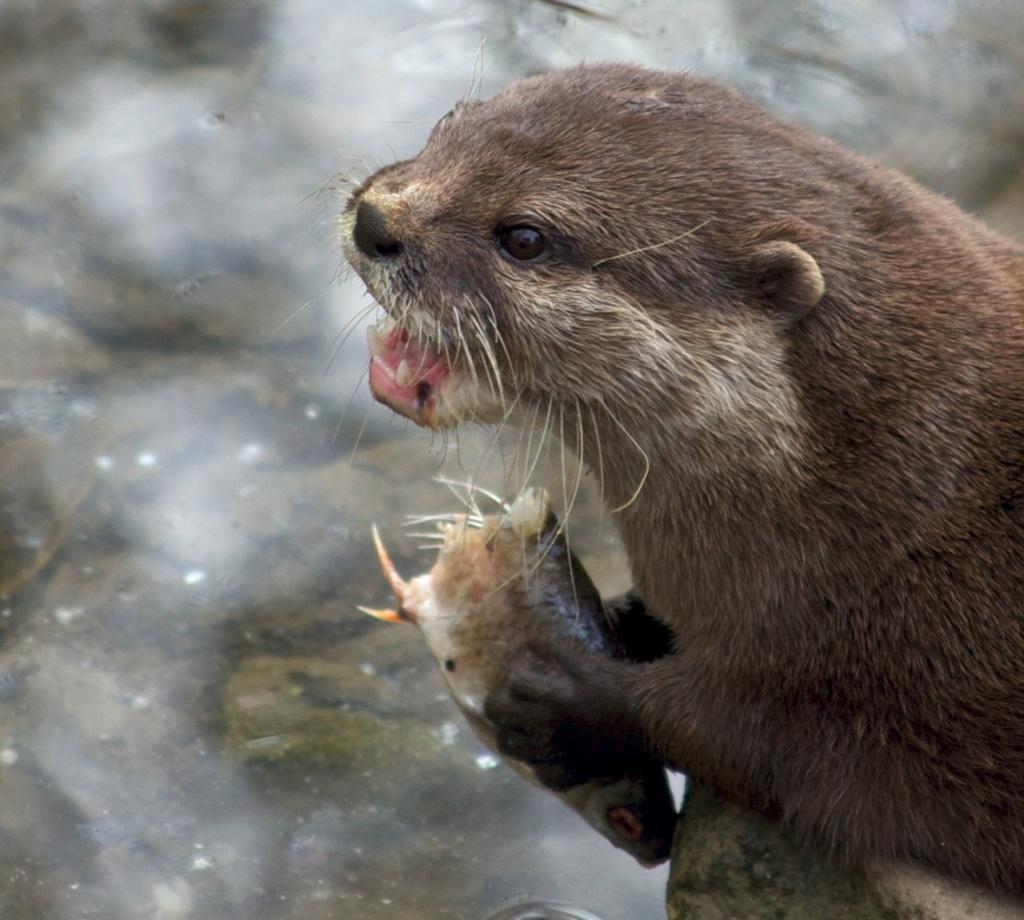Can you describe this image briefly? Here in this picture we can see an animal present over there and it is holding something in its hand and we can see water in front of it all over there. 